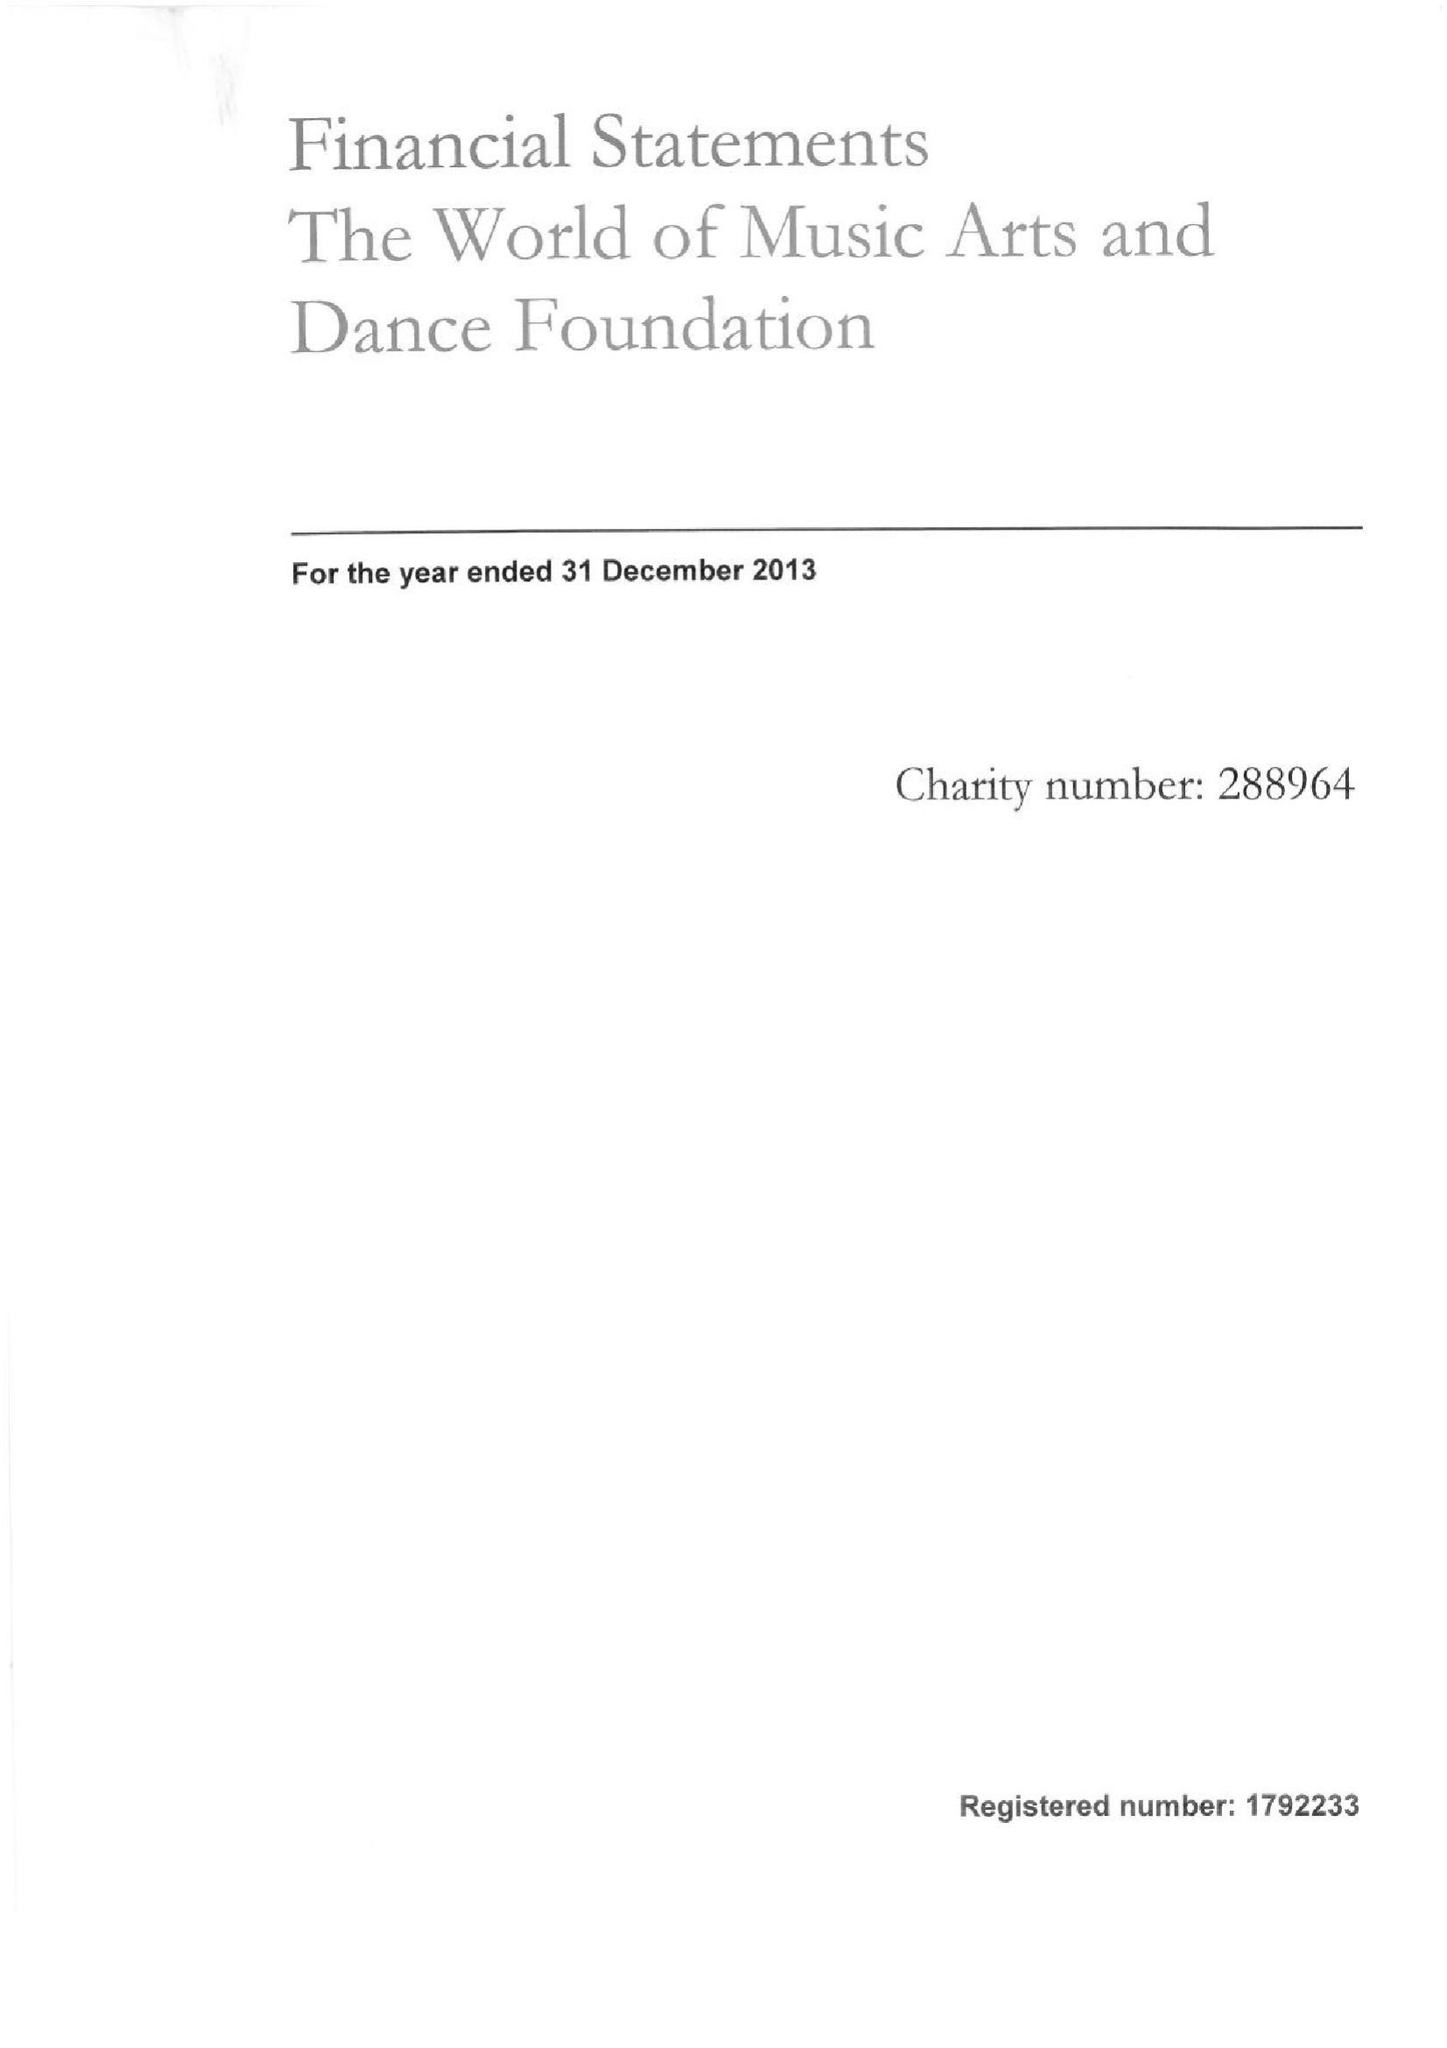What is the value for the charity_name?
Answer the question using a single word or phrase. The World Of Music Arts and Dance Foundation 